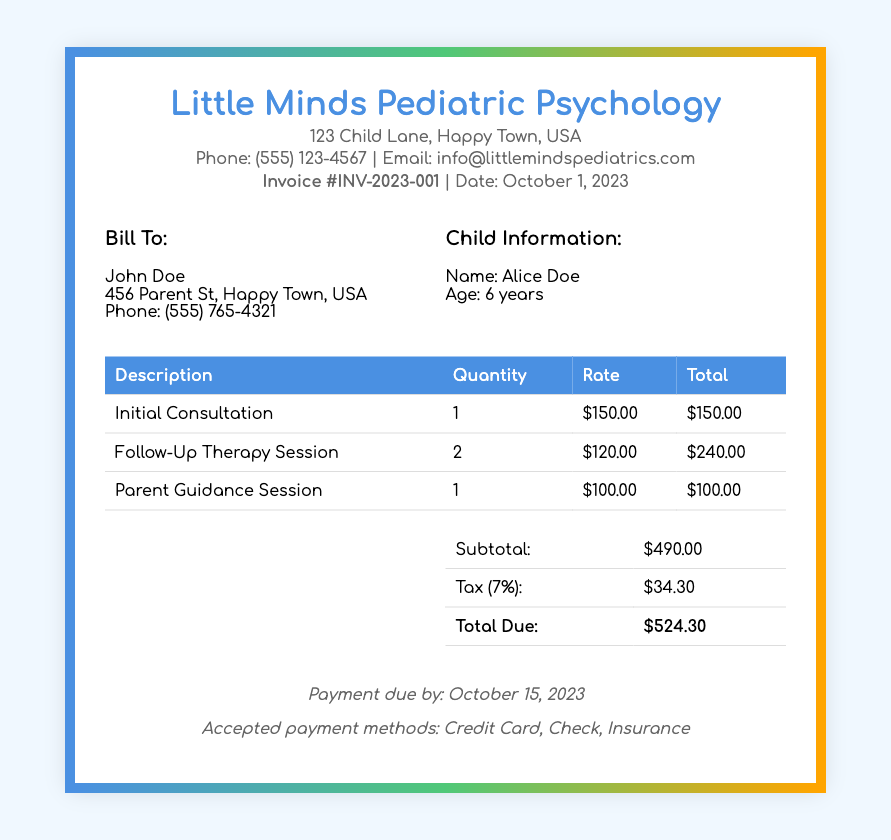What is the invoice number? The invoice number is listed at the top of the document as Invoice #INV-2023-001.
Answer: Invoice #INV-2023-001 What is the total due amount? The total due amount is found in the summary section and is stated as $524.30.
Answer: $524.30 How many follow-up therapy sessions were billed? The document specifies that 2 follow-up therapy sessions were billed in the itemization table.
Answer: 2 What is the hourly rate for an initial consultation? The hourly rate for the initial consultation is specified as $150.00 in the invoice.
Answer: $150.00 What is the tax rate applied to the total? The tax rate is found in the summary and is noted as 7%.
Answer: 7% Who is the child receiving therapy? The child's name is provided in the client information section as Alice Doe.
Answer: Alice Doe What is the due date for payment? The payment due date is specified toward the end of the document as October 15, 2023.
Answer: October 15, 2023 What services were provided apart from therapy sessions? The document lists "Parent Guidance Session" as an additional service provided.
Answer: Parent Guidance Session What is the subtotal before tax? The subtotal before tax is mentioned in the summary section and is $490.00.
Answer: $490.00 